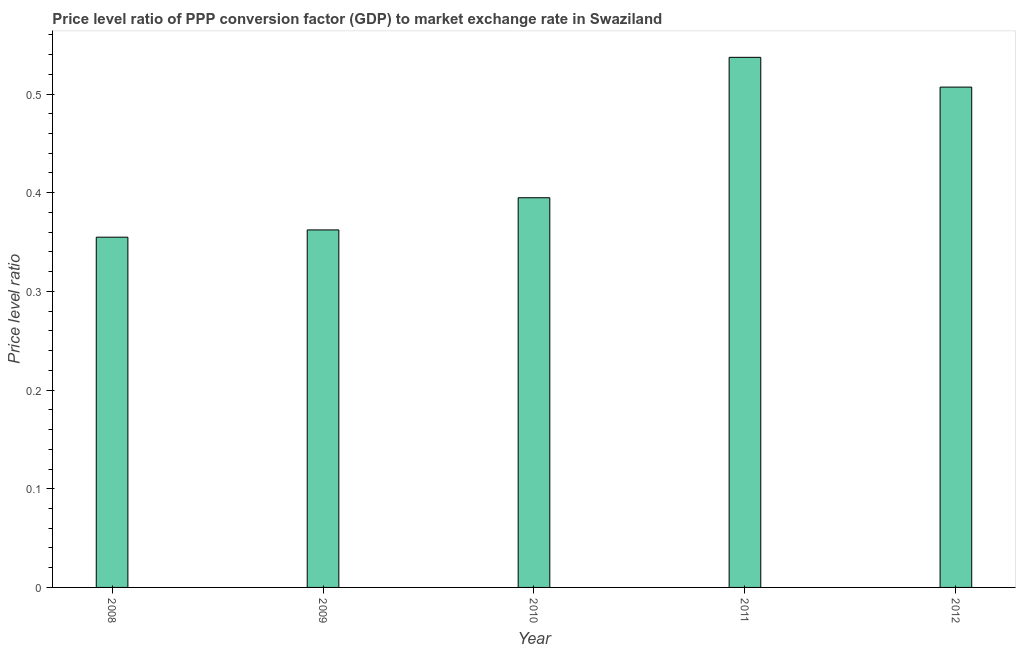What is the title of the graph?
Provide a succinct answer. Price level ratio of PPP conversion factor (GDP) to market exchange rate in Swaziland. What is the label or title of the Y-axis?
Your answer should be very brief. Price level ratio. What is the price level ratio in 2010?
Keep it short and to the point. 0.39. Across all years, what is the maximum price level ratio?
Offer a terse response. 0.54. Across all years, what is the minimum price level ratio?
Ensure brevity in your answer.  0.35. What is the sum of the price level ratio?
Offer a very short reply. 2.16. What is the difference between the price level ratio in 2009 and 2011?
Make the answer very short. -0.17. What is the average price level ratio per year?
Your answer should be very brief. 0.43. What is the median price level ratio?
Provide a short and direct response. 0.39. In how many years, is the price level ratio greater than 0.46 ?
Ensure brevity in your answer.  2. Do a majority of the years between 2008 and 2012 (inclusive) have price level ratio greater than 0.42 ?
Your answer should be compact. No. What is the ratio of the price level ratio in 2011 to that in 2012?
Keep it short and to the point. 1.06. Is the difference between the price level ratio in 2008 and 2009 greater than the difference between any two years?
Make the answer very short. No. What is the difference between the highest and the second highest price level ratio?
Provide a short and direct response. 0.03. What is the difference between the highest and the lowest price level ratio?
Make the answer very short. 0.18. Are all the bars in the graph horizontal?
Give a very brief answer. No. How many years are there in the graph?
Your answer should be very brief. 5. What is the Price level ratio of 2008?
Provide a succinct answer. 0.35. What is the Price level ratio of 2009?
Ensure brevity in your answer.  0.36. What is the Price level ratio of 2010?
Offer a terse response. 0.39. What is the Price level ratio in 2011?
Offer a very short reply. 0.54. What is the Price level ratio in 2012?
Give a very brief answer. 0.51. What is the difference between the Price level ratio in 2008 and 2009?
Give a very brief answer. -0.01. What is the difference between the Price level ratio in 2008 and 2010?
Keep it short and to the point. -0.04. What is the difference between the Price level ratio in 2008 and 2011?
Your response must be concise. -0.18. What is the difference between the Price level ratio in 2008 and 2012?
Offer a terse response. -0.15. What is the difference between the Price level ratio in 2009 and 2010?
Offer a terse response. -0.03. What is the difference between the Price level ratio in 2009 and 2011?
Keep it short and to the point. -0.17. What is the difference between the Price level ratio in 2009 and 2012?
Offer a very short reply. -0.14. What is the difference between the Price level ratio in 2010 and 2011?
Give a very brief answer. -0.14. What is the difference between the Price level ratio in 2010 and 2012?
Provide a succinct answer. -0.11. What is the difference between the Price level ratio in 2011 and 2012?
Your answer should be very brief. 0.03. What is the ratio of the Price level ratio in 2008 to that in 2010?
Your answer should be compact. 0.9. What is the ratio of the Price level ratio in 2008 to that in 2011?
Ensure brevity in your answer.  0.66. What is the ratio of the Price level ratio in 2009 to that in 2010?
Your response must be concise. 0.92. What is the ratio of the Price level ratio in 2009 to that in 2011?
Give a very brief answer. 0.67. What is the ratio of the Price level ratio in 2009 to that in 2012?
Your response must be concise. 0.71. What is the ratio of the Price level ratio in 2010 to that in 2011?
Your answer should be compact. 0.73. What is the ratio of the Price level ratio in 2010 to that in 2012?
Offer a terse response. 0.78. What is the ratio of the Price level ratio in 2011 to that in 2012?
Provide a succinct answer. 1.06. 